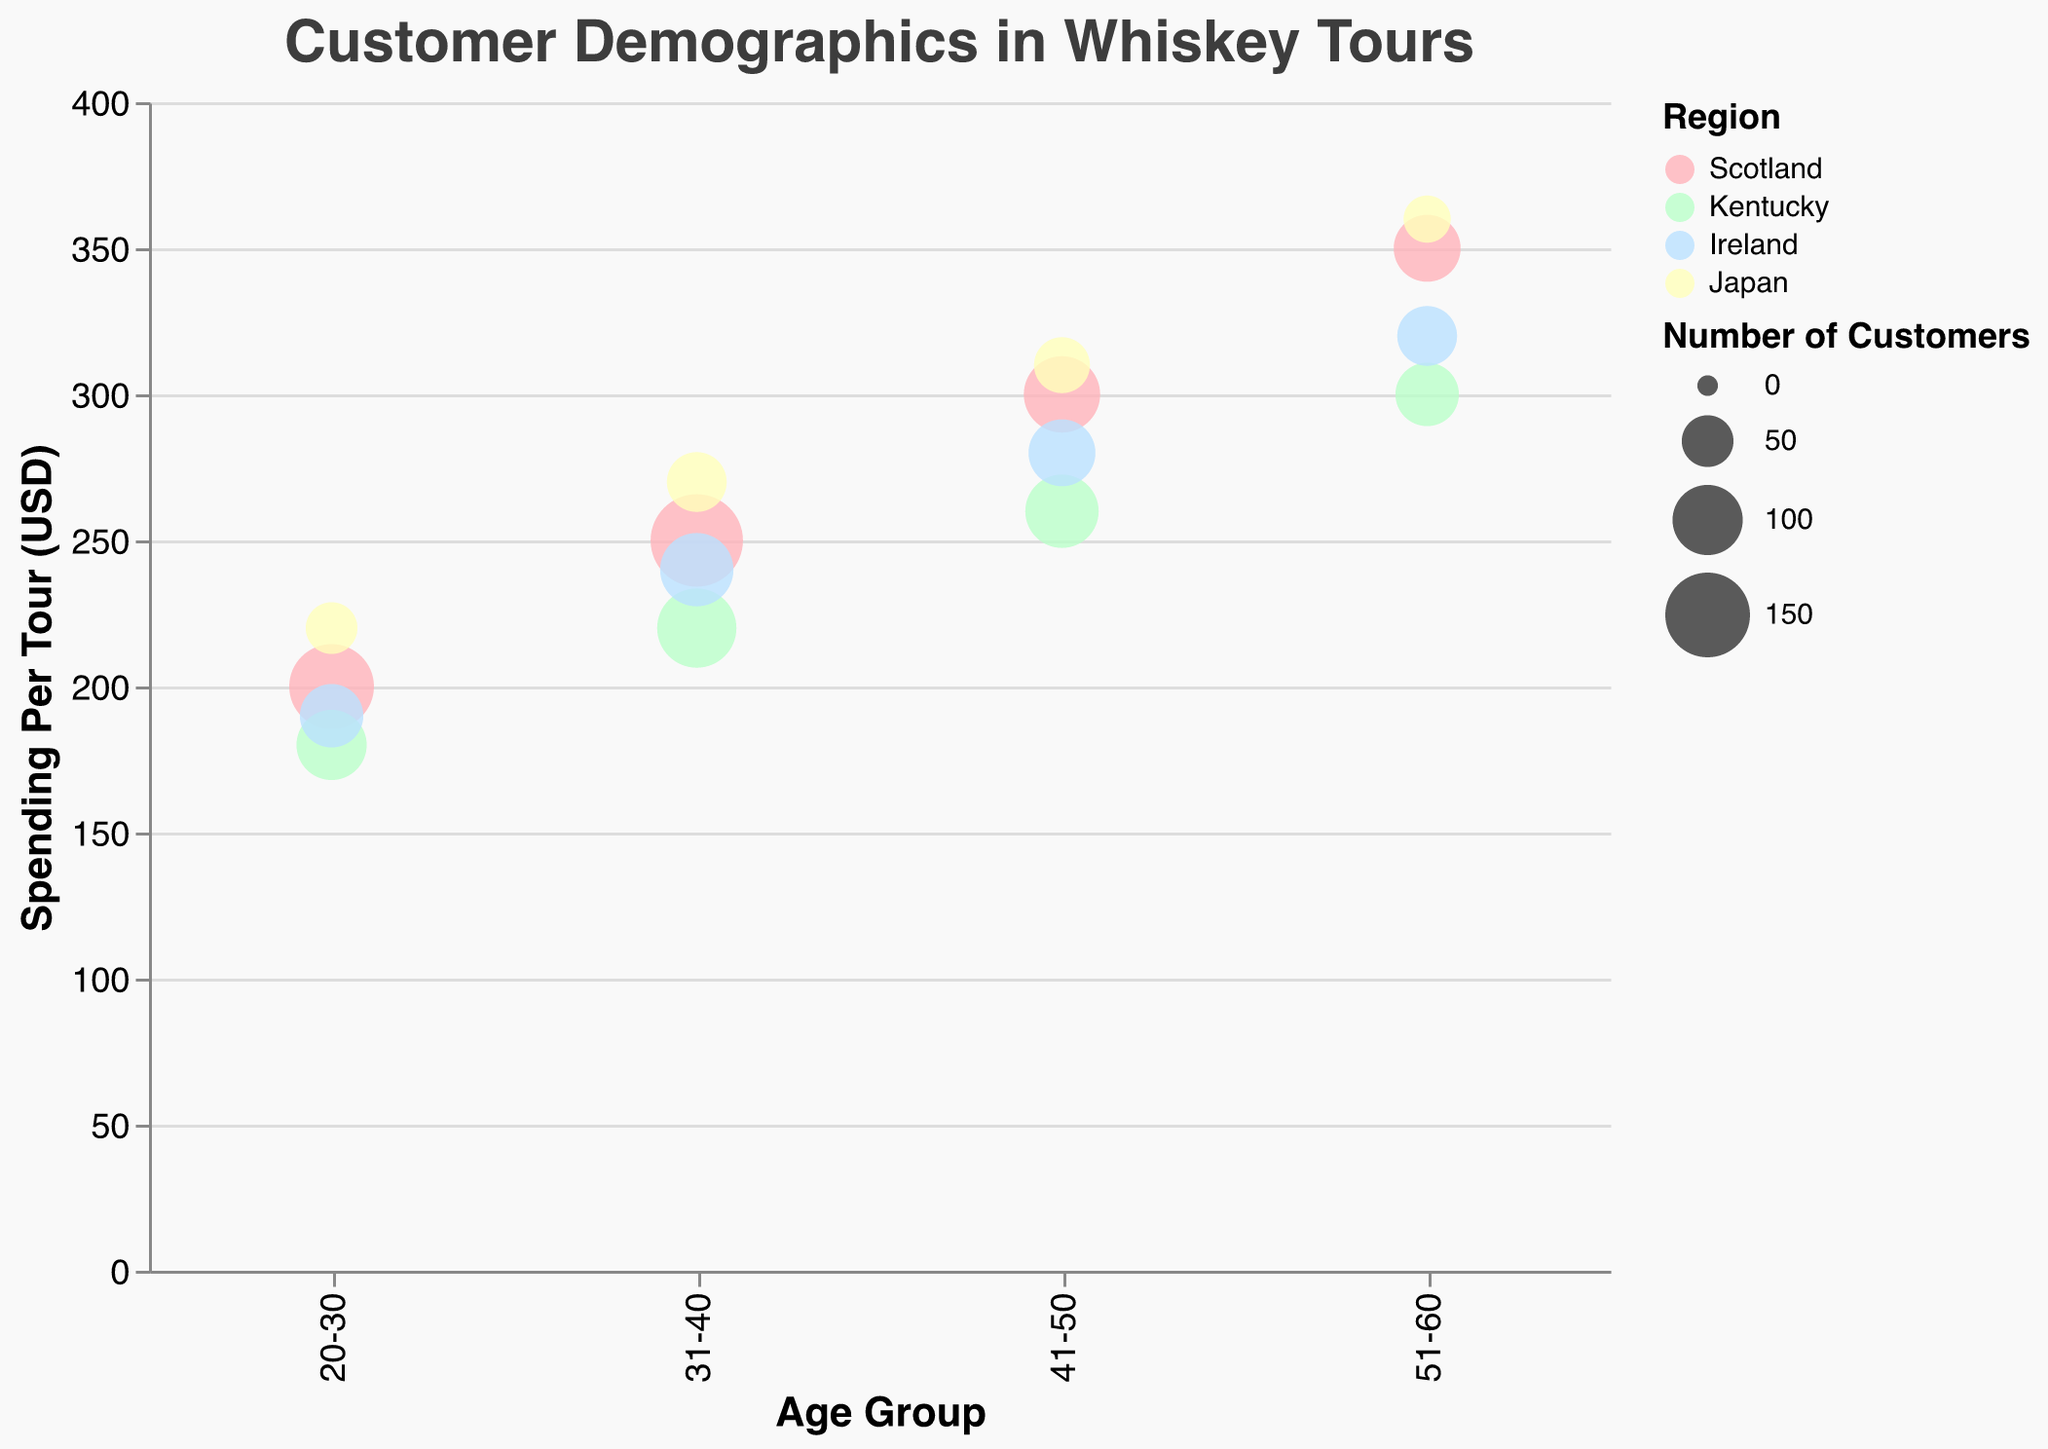What's the title of the chart? The title of the chart can be found at the top and is clearly displayed in larger, bold text.
Answer: Customer Demographics in Whiskey Tours How many regions are represented in the chart, and what are they? There are four distinct color categories representing the regions, indicated by the color legend.
Answer: Four (Scotland, Kentucky, Ireland, Japan) Which age group in Scotland has the highest spending per tour? Look at the bubble representing Scotland and find the one with the highest y-axis placement in the "Spending Per Tour (USD)" category.
Answer: 51-60 Which region has the bubbles with the smallest sizes in the 20-30 age group? Identify the smallest bubbles in the 20-30 age group by comparing their sizes, then find the corresponding region from the color coding.
Answer: Japan How does the spending per tour for the 31-40 age group in Ireland compare to the same age group in Kentucky? Check the y-axis positions of the Ireland and Kentucky bubbles for the 31-40 age group.
Answer: Ireland: 240 USD, Kentucky: 220 USD; Ireland spends more Which region has the overall lowest number of customers in any age group? Look for the smallest size (smallest bubble) across all regions and age groups.
Answer: Japan (40 customers for age 51-60) What is the average spending per tour for the age groups in Japan? Sum the spending per tour amounts for each age group in Japan and divide by the number of groups.
Answer: (220 + 270 + 310 + 360) / 4 = 290 In which region do customers in the 41-50 age group spend the most per tour? Identify the region with the highest y-axis value in the 41-50 age group.
Answer: Japan Compare the number of customers in the 31-40 age group across all regions. Which has the highest and which has the lowest? Look at the size (diameter) of the bubbles for the 31-40 age group and compare them.
Answer: Highest: Scotland (180), Lowest: Japan (70) What trend is observable about spending per tour as age increases in Scotland? Examine the y-axis values for the Scottish bubbles and note the pattern from youngest to oldest age groups.
Answer: Spending increases with age 